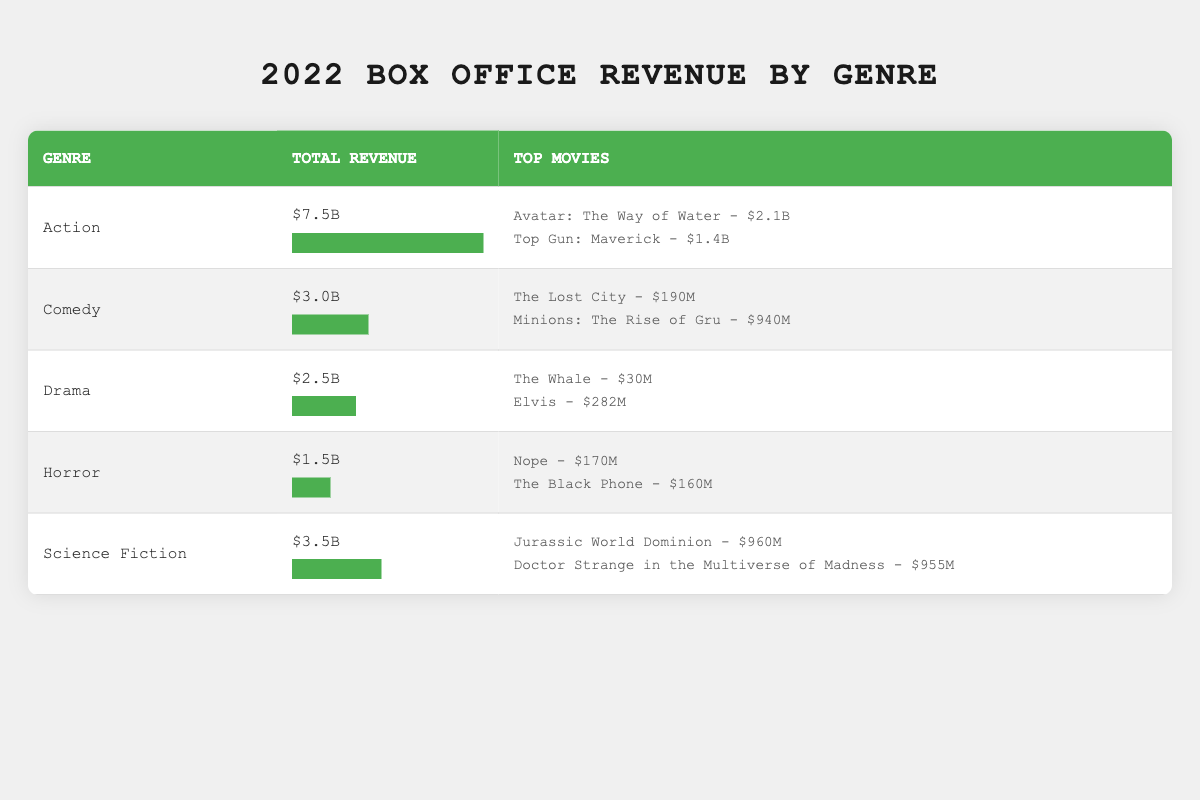What genre had the highest total revenue in 2022? The total revenue for each genre is listed in the table. Action has the highest total revenue at $7.5 billion compared to other genres.
Answer: Action Which movie generated the most revenue in the Action genre? The table lists the top movies under each genre. For Action, "Avatar: The Way of Water" generated $2.1 billion, which is higher than "Top Gun: Maverick" at $1.4 billion.
Answer: Avatar: The Way of Water What is the combined total revenue of Comedy and Horror genres? The total revenue for Comedy is $3 billion and for Horror is $1.5 billion. Adding these amounts: 3 billion + 1.5 billion = 4.5 billion.
Answer: 4.5 billion Is the top movie in the Horror genre above $200 million in revenue? The top movie listed in the Horror genre is "Nope" with $170 million, which is below $200 million. Therefore, the statement is false.
Answer: No Which genre had the lowest revenue, and what was that total? By examining the total revenues for all genres, Horror has the lowest total revenue at $1.5 billion.
Answer: Horror - $1.5 billion What percentage of total revenue does Science Fiction represent compared to Action? Science Fiction total revenue is $3.5 billion and Action is $7.5 billion. To find the percentage, calculate (3.5 billion / 7.5 billion) * 100 = 46.67%.
Answer: 46.67% Which genre has the highest total revenue among the genres that exceed $2 billion? The genres exceeding $2 billion are Action at $7.5 billion, Comedy at $3 billion, and Drama at $2.5 billion. The highest among these is Action at $7.5 billion.
Answer: Action Which top movie from Comedy has the highest revenue? "Minions: The Rise of Gru" has a revenue of $940 million, which is higher than "The Lost City" at $190 million in the Comedy genre.
Answer: Minions: The Rise of Gru True or False: The combined revenue of Drama and Horror is more than $4 billion. Drama has a total revenue of $2.5 billion and Horror has $1.5 billion. The combined total is 2.5 billion + 1.5 billion = 4 billion, which is not more than $4 billion. Therefore, the statement is false.
Answer: False 